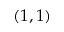Convert formula to latex. <formula><loc_0><loc_0><loc_500><loc_500>( 1 , 1 )</formula> 